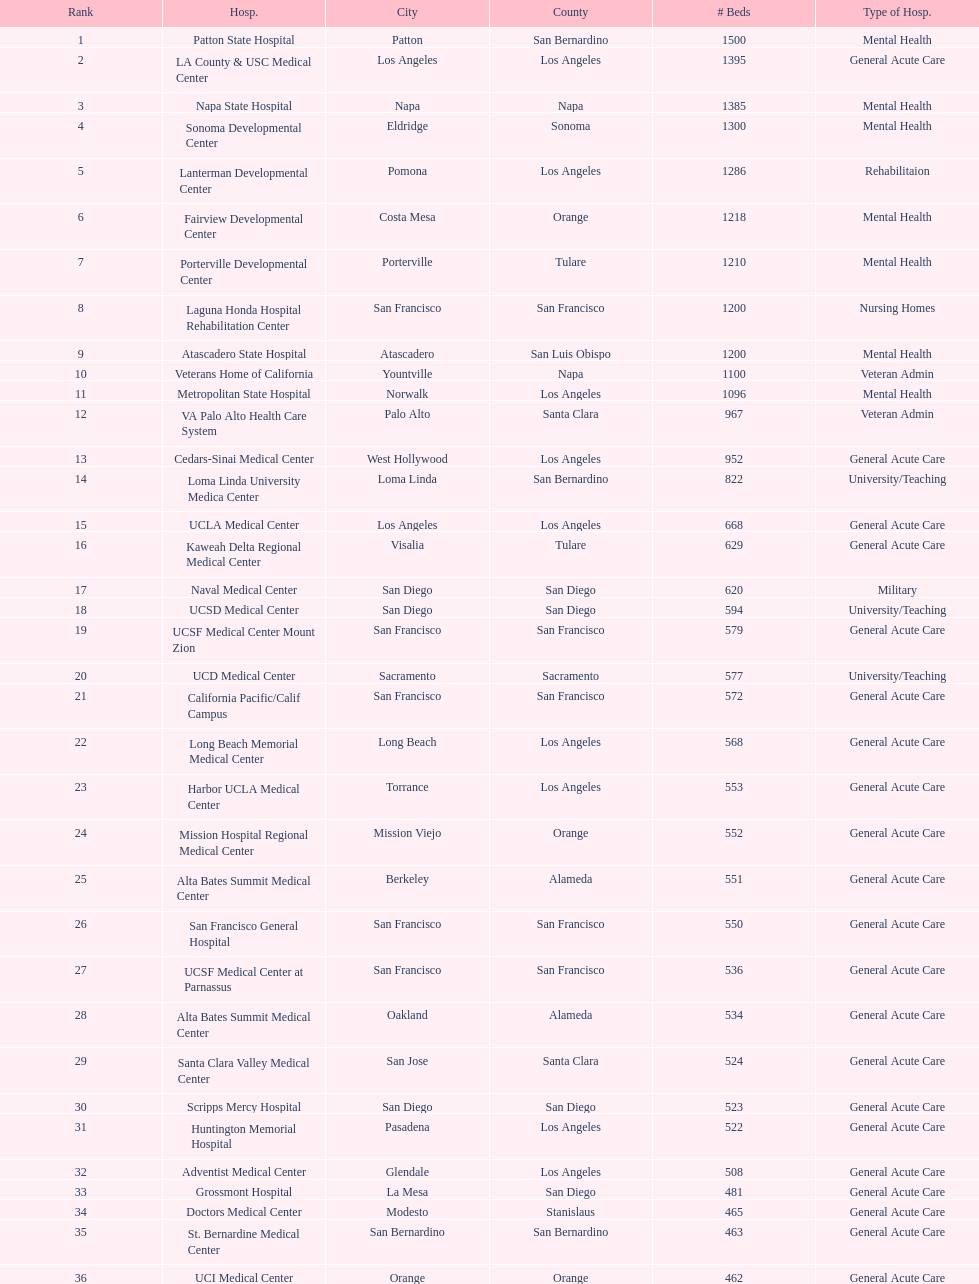Which type of hospitals are the same as grossmont hospital? General Acute Care. Help me parse the entirety of this table. {'header': ['Rank', 'Hosp.', 'City', 'County', '# Beds', 'Type of Hosp.'], 'rows': [['1', 'Patton State Hospital', 'Patton', 'San Bernardino', '1500', 'Mental Health'], ['2', 'LA County & USC Medical Center', 'Los Angeles', 'Los Angeles', '1395', 'General Acute Care'], ['3', 'Napa State Hospital', 'Napa', 'Napa', '1385', 'Mental Health'], ['4', 'Sonoma Developmental Center', 'Eldridge', 'Sonoma', '1300', 'Mental Health'], ['5', 'Lanterman Developmental Center', 'Pomona', 'Los Angeles', '1286', 'Rehabilitaion'], ['6', 'Fairview Developmental Center', 'Costa Mesa', 'Orange', '1218', 'Mental Health'], ['7', 'Porterville Developmental Center', 'Porterville', 'Tulare', '1210', 'Mental Health'], ['8', 'Laguna Honda Hospital Rehabilitation Center', 'San Francisco', 'San Francisco', '1200', 'Nursing Homes'], ['9', 'Atascadero State Hospital', 'Atascadero', 'San Luis Obispo', '1200', 'Mental Health'], ['10', 'Veterans Home of California', 'Yountville', 'Napa', '1100', 'Veteran Admin'], ['11', 'Metropolitan State Hospital', 'Norwalk', 'Los Angeles', '1096', 'Mental Health'], ['12', 'VA Palo Alto Health Care System', 'Palo Alto', 'Santa Clara', '967', 'Veteran Admin'], ['13', 'Cedars-Sinai Medical Center', 'West Hollywood', 'Los Angeles', '952', 'General Acute Care'], ['14', 'Loma Linda University Medica Center', 'Loma Linda', 'San Bernardino', '822', 'University/Teaching'], ['15', 'UCLA Medical Center', 'Los Angeles', 'Los Angeles', '668', 'General Acute Care'], ['16', 'Kaweah Delta Regional Medical Center', 'Visalia', 'Tulare', '629', 'General Acute Care'], ['17', 'Naval Medical Center', 'San Diego', 'San Diego', '620', 'Military'], ['18', 'UCSD Medical Center', 'San Diego', 'San Diego', '594', 'University/Teaching'], ['19', 'UCSF Medical Center Mount Zion', 'San Francisco', 'San Francisco', '579', 'General Acute Care'], ['20', 'UCD Medical Center', 'Sacramento', 'Sacramento', '577', 'University/Teaching'], ['21', 'California Pacific/Calif Campus', 'San Francisco', 'San Francisco', '572', 'General Acute Care'], ['22', 'Long Beach Memorial Medical Center', 'Long Beach', 'Los Angeles', '568', 'General Acute Care'], ['23', 'Harbor UCLA Medical Center', 'Torrance', 'Los Angeles', '553', 'General Acute Care'], ['24', 'Mission Hospital Regional Medical Center', 'Mission Viejo', 'Orange', '552', 'General Acute Care'], ['25', 'Alta Bates Summit Medical Center', 'Berkeley', 'Alameda', '551', 'General Acute Care'], ['26', 'San Francisco General Hospital', 'San Francisco', 'San Francisco', '550', 'General Acute Care'], ['27', 'UCSF Medical Center at Parnassus', 'San Francisco', 'San Francisco', '536', 'General Acute Care'], ['28', 'Alta Bates Summit Medical Center', 'Oakland', 'Alameda', '534', 'General Acute Care'], ['29', 'Santa Clara Valley Medical Center', 'San Jose', 'Santa Clara', '524', 'General Acute Care'], ['30', 'Scripps Mercy Hospital', 'San Diego', 'San Diego', '523', 'General Acute Care'], ['31', 'Huntington Memorial Hospital', 'Pasadena', 'Los Angeles', '522', 'General Acute Care'], ['32', 'Adventist Medical Center', 'Glendale', 'Los Angeles', '508', 'General Acute Care'], ['33', 'Grossmont Hospital', 'La Mesa', 'San Diego', '481', 'General Acute Care'], ['34', 'Doctors Medical Center', 'Modesto', 'Stanislaus', '465', 'General Acute Care'], ['35', 'St. Bernardine Medical Center', 'San Bernardino', 'San Bernardino', '463', 'General Acute Care'], ['36', 'UCI Medical Center', 'Orange', 'Orange', '462', 'General Acute Care'], ['37', 'Stanford Medical Center', 'Stanford', 'Santa Clara', '460', 'General Acute Care'], ['38', 'Community Regional Medical Center', 'Fresno', 'Fresno', '457', 'General Acute Care'], ['39', 'Methodist Hospital', 'Arcadia', 'Los Angeles', '455', 'General Acute Care'], ['40', 'Providence St. Joseph Medical Center', 'Burbank', 'Los Angeles', '455', 'General Acute Care'], ['41', 'Hoag Memorial Hospital', 'Newport Beach', 'Orange', '450', 'General Acute Care'], ['42', 'Agnews Developmental Center', 'San Jose', 'Santa Clara', '450', 'Mental Health'], ['43', 'Jewish Home', 'San Francisco', 'San Francisco', '450', 'Nursing Homes'], ['44', 'St. Joseph Hospital Orange', 'Orange', 'Orange', '448', 'General Acute Care'], ['45', 'Presbyterian Intercommunity', 'Whittier', 'Los Angeles', '441', 'General Acute Care'], ['46', 'Kaiser Permanente Medical Center', 'Fontana', 'San Bernardino', '440', 'General Acute Care'], ['47', 'Kaiser Permanente Medical Center', 'Los Angeles', 'Los Angeles', '439', 'General Acute Care'], ['48', 'Pomona Valley Hospital Medical Center', 'Pomona', 'Los Angeles', '436', 'General Acute Care'], ['49', 'Sutter General Medical Center', 'Sacramento', 'Sacramento', '432', 'General Acute Care'], ['50', 'St. Mary Medical Center', 'San Francisco', 'San Francisco', '430', 'General Acute Care'], ['50', 'Good Samaritan Hospital', 'San Jose', 'Santa Clara', '429', 'General Acute Care']]} 